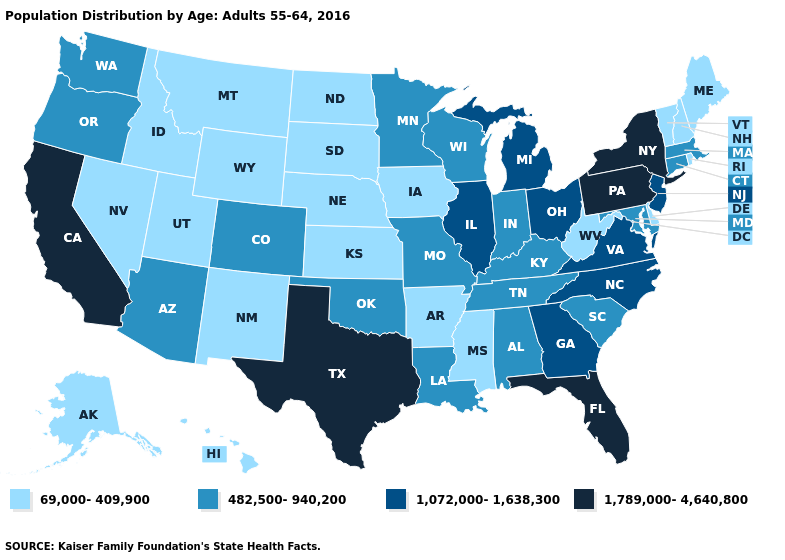Does Tennessee have a lower value than Georgia?
Give a very brief answer. Yes. Among the states that border South Dakota , does Minnesota have the highest value?
Short answer required. Yes. Name the states that have a value in the range 1,072,000-1,638,300?
Answer briefly. Georgia, Illinois, Michigan, New Jersey, North Carolina, Ohio, Virginia. Does California have the highest value in the West?
Keep it brief. Yes. How many symbols are there in the legend?
Short answer required. 4. What is the value of Tennessee?
Keep it brief. 482,500-940,200. Which states hav the highest value in the MidWest?
Quick response, please. Illinois, Michigan, Ohio. Does Arkansas have a lower value than Tennessee?
Be succinct. Yes. What is the highest value in the USA?
Give a very brief answer. 1,789,000-4,640,800. What is the lowest value in the South?
Be succinct. 69,000-409,900. Which states have the highest value in the USA?
Concise answer only. California, Florida, New York, Pennsylvania, Texas. Does Georgia have the lowest value in the USA?
Keep it brief. No. What is the value of Iowa?
Concise answer only. 69,000-409,900. What is the highest value in states that border Minnesota?
Concise answer only. 482,500-940,200. 